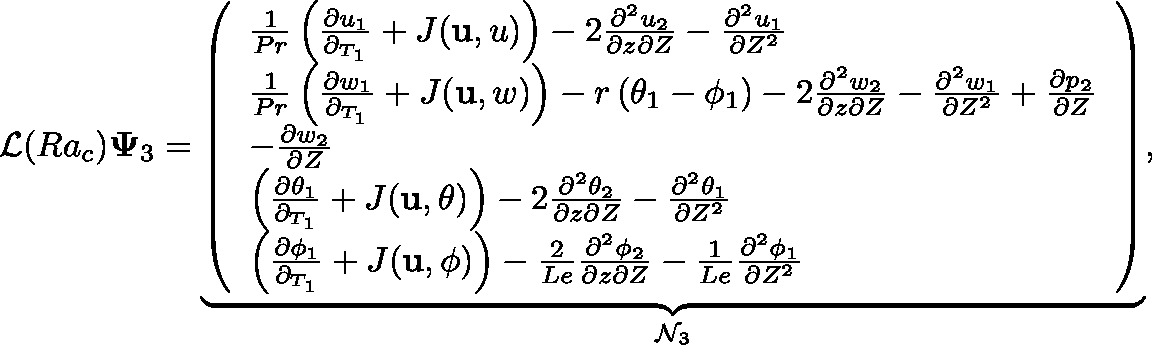Convert formula to latex. <formula><loc_0><loc_0><loc_500><loc_500>\mathcal { L } ( R a _ { c } ) \Psi _ { 3 } = \underbrace { \left ( \begin{array} { l } { \frac { 1 } { P r } \left ( \frac { \partial u _ { 1 } } { \partial _ { T _ { 1 } } } + J ( u , u ) \right ) - 2 \frac { \partial ^ { 2 } u _ { 2 } } { \partial z \partial Z } - \frac { \partial ^ { 2 } u _ { 1 } } { \partial Z ^ { 2 } } } \\ { \frac { 1 } { P r } \left ( \frac { \partial w _ { 1 } } { \partial _ { T _ { 1 } } } + J ( u , w ) \right ) - r \left ( \theta _ { 1 } - \phi _ { 1 } \right ) - 2 \frac { \partial ^ { 2 } w _ { 2 } } { \partial z \partial Z } - \frac { \partial ^ { 2 } w _ { 1 } } { \partial Z ^ { 2 } } + \frac { \partial p _ { 2 } } { \partial Z } } \\ { - \frac { \partial w _ { 2 } } { \partial Z } } \\ { \left ( \frac { \partial \theta _ { 1 } } { \partial _ { T _ { 1 } } } + J ( u , \theta ) \right ) - 2 \frac { \partial ^ { 2 } \theta _ { 2 } } { \partial z \partial Z } - \frac { \partial ^ { 2 } \theta _ { 1 } } { \partial Z ^ { 2 } } } \\ { \left ( \frac { \partial \phi _ { 1 } } { \partial _ { T _ { 1 } } } + J ( u , \phi ) \right ) - \frac { 2 } { L e } \frac { \partial ^ { 2 } \phi _ { 2 } } { \partial z \partial Z } - \frac { 1 } { L e } \frac { \partial ^ { 2 } \phi _ { 1 } } { \partial Z ^ { 2 } } } \end{array} \right ) } _ { \mathcal { N } _ { 3 } } ,</formula> 